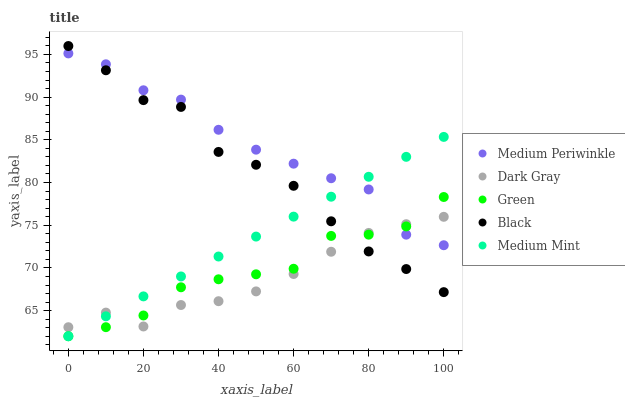Does Dark Gray have the minimum area under the curve?
Answer yes or no. Yes. Does Medium Periwinkle have the maximum area under the curve?
Answer yes or no. Yes. Does Green have the minimum area under the curve?
Answer yes or no. No. Does Green have the maximum area under the curve?
Answer yes or no. No. Is Medium Mint the smoothest?
Answer yes or no. Yes. Is Black the roughest?
Answer yes or no. Yes. Is Green the smoothest?
Answer yes or no. No. Is Green the roughest?
Answer yes or no. No. Does Green have the lowest value?
Answer yes or no. Yes. Does Medium Periwinkle have the lowest value?
Answer yes or no. No. Does Black have the highest value?
Answer yes or no. Yes. Does Green have the highest value?
Answer yes or no. No. Does Medium Mint intersect Dark Gray?
Answer yes or no. Yes. Is Medium Mint less than Dark Gray?
Answer yes or no. No. Is Medium Mint greater than Dark Gray?
Answer yes or no. No. 